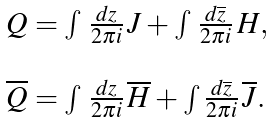<formula> <loc_0><loc_0><loc_500><loc_500>\begin{array} { l } Q = \int \, \frac { d z } { 2 \pi i } \, J + \int \, \frac { d \overline { z } } { 2 \pi i } \, H , \\ \\ \overline { Q } = \int \, \frac { d z } { 2 \pi i } \, \overline { H } + \int \frac { d \overline { z } } { 2 \pi i } \, \overline { J } . \end{array}</formula> 